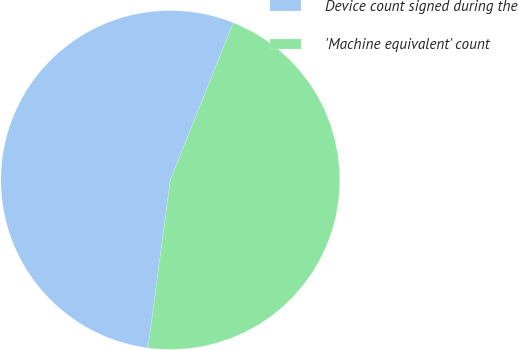Convert chart. <chart><loc_0><loc_0><loc_500><loc_500><pie_chart><fcel>Device count signed during the<fcel>'Machine equivalent' count<nl><fcel>53.96%<fcel>46.04%<nl></chart> 